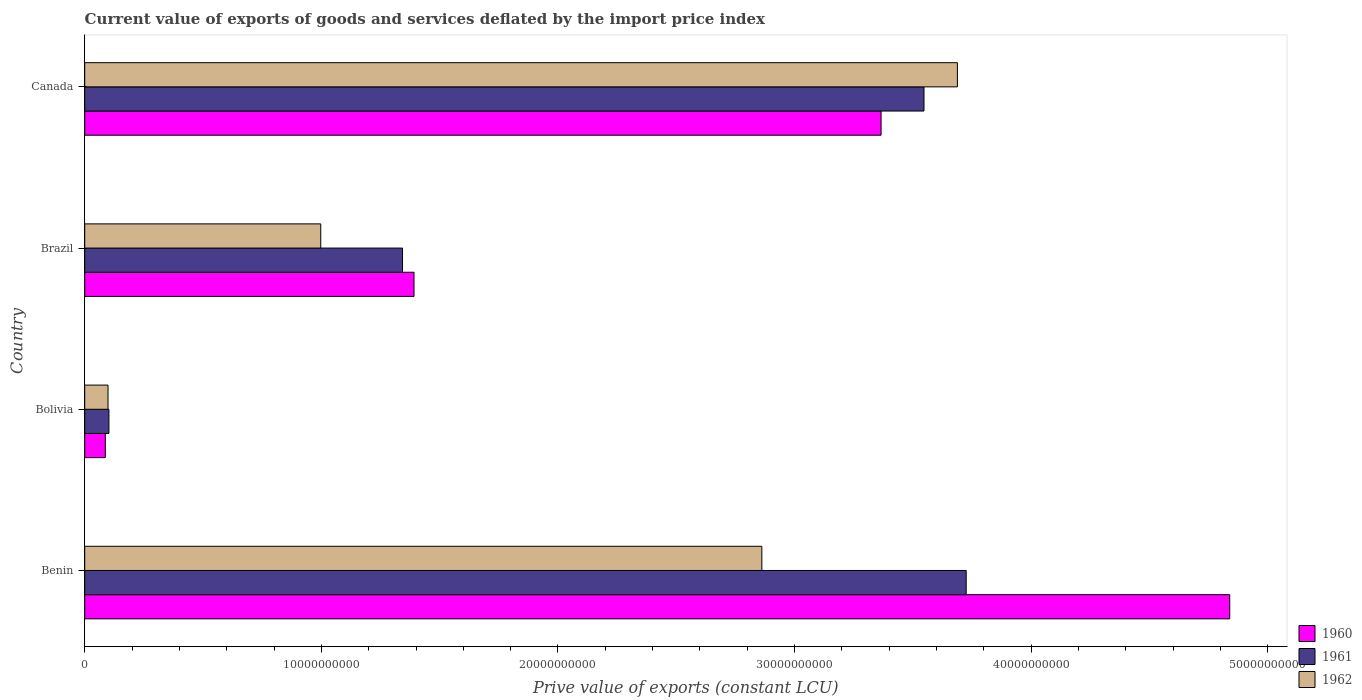How many different coloured bars are there?
Ensure brevity in your answer.  3. How many groups of bars are there?
Your response must be concise. 4. Are the number of bars per tick equal to the number of legend labels?
Give a very brief answer. Yes. Are the number of bars on each tick of the Y-axis equal?
Keep it short and to the point. Yes. How many bars are there on the 3rd tick from the top?
Your answer should be compact. 3. What is the prive value of exports in 1961 in Benin?
Your response must be concise. 3.73e+1. Across all countries, what is the maximum prive value of exports in 1962?
Keep it short and to the point. 3.69e+1. Across all countries, what is the minimum prive value of exports in 1960?
Give a very brief answer. 8.70e+08. In which country was the prive value of exports in 1961 maximum?
Keep it short and to the point. Benin. What is the total prive value of exports in 1960 in the graph?
Your answer should be compact. 9.68e+1. What is the difference between the prive value of exports in 1961 in Benin and that in Canada?
Keep it short and to the point. 1.78e+09. What is the difference between the prive value of exports in 1961 in Canada and the prive value of exports in 1960 in Benin?
Provide a succinct answer. -1.29e+1. What is the average prive value of exports in 1962 per country?
Offer a terse response. 1.91e+1. What is the difference between the prive value of exports in 1961 and prive value of exports in 1960 in Brazil?
Ensure brevity in your answer.  -4.85e+08. What is the ratio of the prive value of exports in 1962 in Benin to that in Bolivia?
Your answer should be very brief. 29.05. What is the difference between the highest and the second highest prive value of exports in 1961?
Give a very brief answer. 1.78e+09. What is the difference between the highest and the lowest prive value of exports in 1961?
Your response must be concise. 3.62e+1. In how many countries, is the prive value of exports in 1961 greater than the average prive value of exports in 1961 taken over all countries?
Make the answer very short. 2. What does the 1st bar from the top in Brazil represents?
Your answer should be very brief. 1962. What does the 3rd bar from the bottom in Bolivia represents?
Make the answer very short. 1962. Are all the bars in the graph horizontal?
Your answer should be compact. Yes. What is the difference between two consecutive major ticks on the X-axis?
Make the answer very short. 1.00e+1. Are the values on the major ticks of X-axis written in scientific E-notation?
Ensure brevity in your answer.  No. Does the graph contain grids?
Provide a short and direct response. No. How many legend labels are there?
Offer a very short reply. 3. What is the title of the graph?
Your answer should be compact. Current value of exports of goods and services deflated by the import price index. What is the label or title of the X-axis?
Give a very brief answer. Prive value of exports (constant LCU). What is the Prive value of exports (constant LCU) of 1960 in Benin?
Keep it short and to the point. 4.84e+1. What is the Prive value of exports (constant LCU) in 1961 in Benin?
Make the answer very short. 3.73e+1. What is the Prive value of exports (constant LCU) in 1962 in Benin?
Keep it short and to the point. 2.86e+1. What is the Prive value of exports (constant LCU) in 1960 in Bolivia?
Your response must be concise. 8.70e+08. What is the Prive value of exports (constant LCU) in 1961 in Bolivia?
Offer a very short reply. 1.02e+09. What is the Prive value of exports (constant LCU) of 1962 in Bolivia?
Offer a very short reply. 9.85e+08. What is the Prive value of exports (constant LCU) in 1960 in Brazil?
Offer a terse response. 1.39e+1. What is the Prive value of exports (constant LCU) in 1961 in Brazil?
Your answer should be compact. 1.34e+1. What is the Prive value of exports (constant LCU) of 1962 in Brazil?
Ensure brevity in your answer.  9.97e+09. What is the Prive value of exports (constant LCU) of 1960 in Canada?
Provide a short and direct response. 3.37e+1. What is the Prive value of exports (constant LCU) in 1961 in Canada?
Provide a succinct answer. 3.55e+1. What is the Prive value of exports (constant LCU) in 1962 in Canada?
Give a very brief answer. 3.69e+1. Across all countries, what is the maximum Prive value of exports (constant LCU) in 1960?
Offer a very short reply. 4.84e+1. Across all countries, what is the maximum Prive value of exports (constant LCU) of 1961?
Your response must be concise. 3.73e+1. Across all countries, what is the maximum Prive value of exports (constant LCU) of 1962?
Ensure brevity in your answer.  3.69e+1. Across all countries, what is the minimum Prive value of exports (constant LCU) in 1960?
Offer a terse response. 8.70e+08. Across all countries, what is the minimum Prive value of exports (constant LCU) of 1961?
Offer a very short reply. 1.02e+09. Across all countries, what is the minimum Prive value of exports (constant LCU) in 1962?
Offer a very short reply. 9.85e+08. What is the total Prive value of exports (constant LCU) of 1960 in the graph?
Make the answer very short. 9.68e+1. What is the total Prive value of exports (constant LCU) in 1961 in the graph?
Ensure brevity in your answer.  8.72e+1. What is the total Prive value of exports (constant LCU) of 1962 in the graph?
Your answer should be very brief. 7.65e+1. What is the difference between the Prive value of exports (constant LCU) in 1960 in Benin and that in Bolivia?
Your answer should be compact. 4.75e+1. What is the difference between the Prive value of exports (constant LCU) of 1961 in Benin and that in Bolivia?
Offer a terse response. 3.62e+1. What is the difference between the Prive value of exports (constant LCU) in 1962 in Benin and that in Bolivia?
Make the answer very short. 2.76e+1. What is the difference between the Prive value of exports (constant LCU) of 1960 in Benin and that in Brazil?
Make the answer very short. 3.45e+1. What is the difference between the Prive value of exports (constant LCU) in 1961 in Benin and that in Brazil?
Your answer should be very brief. 2.38e+1. What is the difference between the Prive value of exports (constant LCU) of 1962 in Benin and that in Brazil?
Provide a succinct answer. 1.86e+1. What is the difference between the Prive value of exports (constant LCU) of 1960 in Benin and that in Canada?
Provide a succinct answer. 1.47e+1. What is the difference between the Prive value of exports (constant LCU) in 1961 in Benin and that in Canada?
Your answer should be compact. 1.78e+09. What is the difference between the Prive value of exports (constant LCU) of 1962 in Benin and that in Canada?
Make the answer very short. -8.26e+09. What is the difference between the Prive value of exports (constant LCU) in 1960 in Bolivia and that in Brazil?
Give a very brief answer. -1.30e+1. What is the difference between the Prive value of exports (constant LCU) in 1961 in Bolivia and that in Brazil?
Keep it short and to the point. -1.24e+1. What is the difference between the Prive value of exports (constant LCU) of 1962 in Bolivia and that in Brazil?
Provide a short and direct response. -8.99e+09. What is the difference between the Prive value of exports (constant LCU) in 1960 in Bolivia and that in Canada?
Provide a short and direct response. -3.28e+1. What is the difference between the Prive value of exports (constant LCU) in 1961 in Bolivia and that in Canada?
Your answer should be very brief. -3.44e+1. What is the difference between the Prive value of exports (constant LCU) of 1962 in Bolivia and that in Canada?
Offer a terse response. -3.59e+1. What is the difference between the Prive value of exports (constant LCU) in 1960 in Brazil and that in Canada?
Your answer should be very brief. -1.97e+1. What is the difference between the Prive value of exports (constant LCU) in 1961 in Brazil and that in Canada?
Your response must be concise. -2.20e+1. What is the difference between the Prive value of exports (constant LCU) in 1962 in Brazil and that in Canada?
Your answer should be compact. -2.69e+1. What is the difference between the Prive value of exports (constant LCU) of 1960 in Benin and the Prive value of exports (constant LCU) of 1961 in Bolivia?
Give a very brief answer. 4.74e+1. What is the difference between the Prive value of exports (constant LCU) in 1960 in Benin and the Prive value of exports (constant LCU) in 1962 in Bolivia?
Make the answer very short. 4.74e+1. What is the difference between the Prive value of exports (constant LCU) of 1961 in Benin and the Prive value of exports (constant LCU) of 1962 in Bolivia?
Your response must be concise. 3.63e+1. What is the difference between the Prive value of exports (constant LCU) of 1960 in Benin and the Prive value of exports (constant LCU) of 1961 in Brazil?
Offer a terse response. 3.50e+1. What is the difference between the Prive value of exports (constant LCU) in 1960 in Benin and the Prive value of exports (constant LCU) in 1962 in Brazil?
Your response must be concise. 3.84e+1. What is the difference between the Prive value of exports (constant LCU) of 1961 in Benin and the Prive value of exports (constant LCU) of 1962 in Brazil?
Provide a short and direct response. 2.73e+1. What is the difference between the Prive value of exports (constant LCU) in 1960 in Benin and the Prive value of exports (constant LCU) in 1961 in Canada?
Offer a terse response. 1.29e+1. What is the difference between the Prive value of exports (constant LCU) of 1960 in Benin and the Prive value of exports (constant LCU) of 1962 in Canada?
Offer a very short reply. 1.15e+1. What is the difference between the Prive value of exports (constant LCU) of 1961 in Benin and the Prive value of exports (constant LCU) of 1962 in Canada?
Your answer should be compact. 3.72e+08. What is the difference between the Prive value of exports (constant LCU) of 1960 in Bolivia and the Prive value of exports (constant LCU) of 1961 in Brazil?
Keep it short and to the point. -1.26e+1. What is the difference between the Prive value of exports (constant LCU) in 1960 in Bolivia and the Prive value of exports (constant LCU) in 1962 in Brazil?
Your response must be concise. -9.10e+09. What is the difference between the Prive value of exports (constant LCU) of 1961 in Bolivia and the Prive value of exports (constant LCU) of 1962 in Brazil?
Ensure brevity in your answer.  -8.95e+09. What is the difference between the Prive value of exports (constant LCU) of 1960 in Bolivia and the Prive value of exports (constant LCU) of 1961 in Canada?
Your answer should be compact. -3.46e+1. What is the difference between the Prive value of exports (constant LCU) of 1960 in Bolivia and the Prive value of exports (constant LCU) of 1962 in Canada?
Provide a short and direct response. -3.60e+1. What is the difference between the Prive value of exports (constant LCU) of 1961 in Bolivia and the Prive value of exports (constant LCU) of 1962 in Canada?
Keep it short and to the point. -3.59e+1. What is the difference between the Prive value of exports (constant LCU) in 1960 in Brazil and the Prive value of exports (constant LCU) in 1961 in Canada?
Provide a succinct answer. -2.16e+1. What is the difference between the Prive value of exports (constant LCU) in 1960 in Brazil and the Prive value of exports (constant LCU) in 1962 in Canada?
Give a very brief answer. -2.30e+1. What is the difference between the Prive value of exports (constant LCU) of 1961 in Brazil and the Prive value of exports (constant LCU) of 1962 in Canada?
Give a very brief answer. -2.34e+1. What is the average Prive value of exports (constant LCU) of 1960 per country?
Ensure brevity in your answer.  2.42e+1. What is the average Prive value of exports (constant LCU) of 1961 per country?
Make the answer very short. 2.18e+1. What is the average Prive value of exports (constant LCU) of 1962 per country?
Make the answer very short. 1.91e+1. What is the difference between the Prive value of exports (constant LCU) in 1960 and Prive value of exports (constant LCU) in 1961 in Benin?
Your answer should be very brief. 1.11e+1. What is the difference between the Prive value of exports (constant LCU) in 1960 and Prive value of exports (constant LCU) in 1962 in Benin?
Your response must be concise. 1.98e+1. What is the difference between the Prive value of exports (constant LCU) in 1961 and Prive value of exports (constant LCU) in 1962 in Benin?
Ensure brevity in your answer.  8.64e+09. What is the difference between the Prive value of exports (constant LCU) of 1960 and Prive value of exports (constant LCU) of 1961 in Bolivia?
Make the answer very short. -1.53e+08. What is the difference between the Prive value of exports (constant LCU) in 1960 and Prive value of exports (constant LCU) in 1962 in Bolivia?
Give a very brief answer. -1.15e+08. What is the difference between the Prive value of exports (constant LCU) in 1961 and Prive value of exports (constant LCU) in 1962 in Bolivia?
Offer a terse response. 3.86e+07. What is the difference between the Prive value of exports (constant LCU) in 1960 and Prive value of exports (constant LCU) in 1961 in Brazil?
Provide a succinct answer. 4.85e+08. What is the difference between the Prive value of exports (constant LCU) in 1960 and Prive value of exports (constant LCU) in 1962 in Brazil?
Provide a succinct answer. 3.94e+09. What is the difference between the Prive value of exports (constant LCU) of 1961 and Prive value of exports (constant LCU) of 1962 in Brazil?
Your response must be concise. 3.46e+09. What is the difference between the Prive value of exports (constant LCU) in 1960 and Prive value of exports (constant LCU) in 1961 in Canada?
Your answer should be very brief. -1.81e+09. What is the difference between the Prive value of exports (constant LCU) of 1960 and Prive value of exports (constant LCU) of 1962 in Canada?
Keep it short and to the point. -3.23e+09. What is the difference between the Prive value of exports (constant LCU) in 1961 and Prive value of exports (constant LCU) in 1962 in Canada?
Offer a very short reply. -1.41e+09. What is the ratio of the Prive value of exports (constant LCU) of 1960 in Benin to that in Bolivia?
Ensure brevity in your answer.  55.59. What is the ratio of the Prive value of exports (constant LCU) of 1961 in Benin to that in Bolivia?
Give a very brief answer. 36.39. What is the ratio of the Prive value of exports (constant LCU) in 1962 in Benin to that in Bolivia?
Ensure brevity in your answer.  29.05. What is the ratio of the Prive value of exports (constant LCU) of 1960 in Benin to that in Brazil?
Offer a very short reply. 3.48. What is the ratio of the Prive value of exports (constant LCU) in 1961 in Benin to that in Brazil?
Provide a succinct answer. 2.77. What is the ratio of the Prive value of exports (constant LCU) in 1962 in Benin to that in Brazil?
Offer a very short reply. 2.87. What is the ratio of the Prive value of exports (constant LCU) in 1960 in Benin to that in Canada?
Provide a short and direct response. 1.44. What is the ratio of the Prive value of exports (constant LCU) of 1961 in Benin to that in Canada?
Your response must be concise. 1.05. What is the ratio of the Prive value of exports (constant LCU) in 1962 in Benin to that in Canada?
Keep it short and to the point. 0.78. What is the ratio of the Prive value of exports (constant LCU) in 1960 in Bolivia to that in Brazil?
Keep it short and to the point. 0.06. What is the ratio of the Prive value of exports (constant LCU) in 1961 in Bolivia to that in Brazil?
Make the answer very short. 0.08. What is the ratio of the Prive value of exports (constant LCU) of 1962 in Bolivia to that in Brazil?
Your answer should be very brief. 0.1. What is the ratio of the Prive value of exports (constant LCU) of 1960 in Bolivia to that in Canada?
Make the answer very short. 0.03. What is the ratio of the Prive value of exports (constant LCU) of 1961 in Bolivia to that in Canada?
Offer a terse response. 0.03. What is the ratio of the Prive value of exports (constant LCU) in 1962 in Bolivia to that in Canada?
Give a very brief answer. 0.03. What is the ratio of the Prive value of exports (constant LCU) in 1960 in Brazil to that in Canada?
Your answer should be very brief. 0.41. What is the ratio of the Prive value of exports (constant LCU) in 1961 in Brazil to that in Canada?
Give a very brief answer. 0.38. What is the ratio of the Prive value of exports (constant LCU) in 1962 in Brazil to that in Canada?
Ensure brevity in your answer.  0.27. What is the difference between the highest and the second highest Prive value of exports (constant LCU) of 1960?
Your answer should be very brief. 1.47e+1. What is the difference between the highest and the second highest Prive value of exports (constant LCU) of 1961?
Your response must be concise. 1.78e+09. What is the difference between the highest and the second highest Prive value of exports (constant LCU) of 1962?
Provide a short and direct response. 8.26e+09. What is the difference between the highest and the lowest Prive value of exports (constant LCU) of 1960?
Provide a succinct answer. 4.75e+1. What is the difference between the highest and the lowest Prive value of exports (constant LCU) in 1961?
Give a very brief answer. 3.62e+1. What is the difference between the highest and the lowest Prive value of exports (constant LCU) in 1962?
Your answer should be very brief. 3.59e+1. 